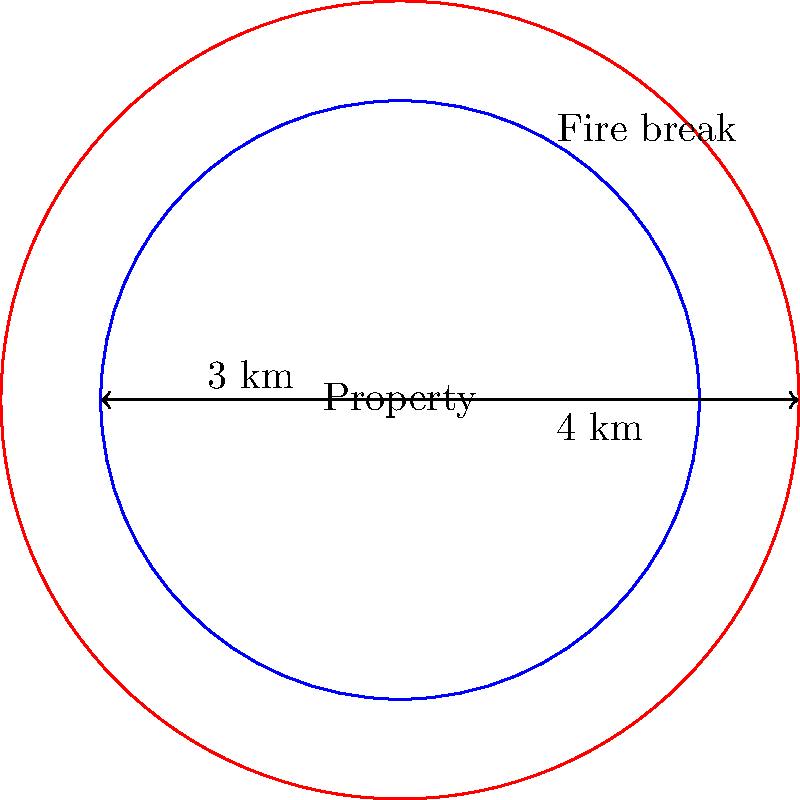A circular property with a radius of 3 km needs a fire break around its perimeter. If the outer edge of the fire break is 4 km from the center of the property, what is the area of the fire break in square kilometers? To find the area of the fire break, we need to:

1. Calculate the area of the larger circle (including the property and fire break):
   $$A_1 = \pi r_1^2 = \pi (4 \text{ km})^2 = 16\pi \text{ km}^2$$

2. Calculate the area of the smaller circle (the property):
   $$A_2 = \pi r_2^2 = \pi (3 \text{ km})^2 = 9\pi \text{ km}^2$$

3. Subtract the area of the property from the total area:
   $$A_{\text{fire break}} = A_1 - A_2 = 16\pi \text{ km}^2 - 9\pi \text{ km}^2 = 7\pi \text{ km}^2$$

4. Simplify the result:
   $$A_{\text{fire break}} = 7\pi \text{ km}^2 \approx 21.99 \text{ km}^2$$

Therefore, the area of the fire break is approximately 21.99 square kilometers.
Answer: $21.99 \text{ km}^2$ 